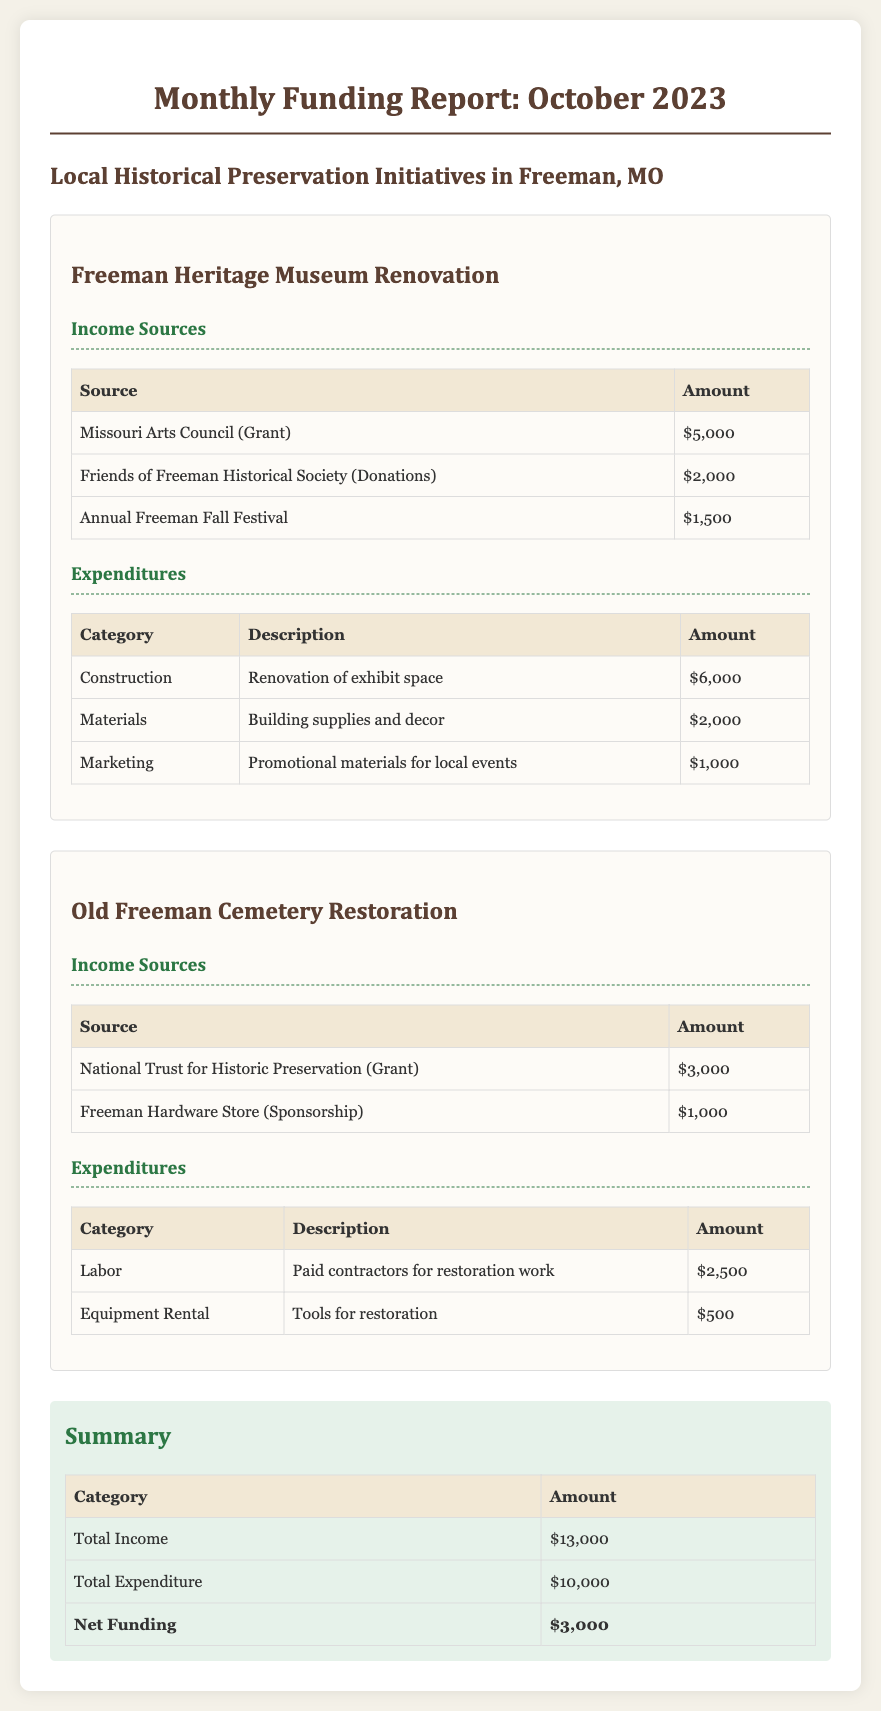What is the total income for October 2023? The total income is the sum of all income sources listed in the document, which is $5,000 + $2,000 + $1,500 + $3,000 + $1,000 = $13,000.
Answer: $13,000 What is the amount allocated for construction in the Freeman Heritage Museum Renovation? The construction expenditure for the Freeman Heritage Museum Renovation is $6,000 as displayed in the expenditures table.
Answer: $6,000 What is the name of the grant received from the Missouri Arts Council? The grant received from the Missouri Arts Council is specifically noted in the income sources of the Freeman Heritage Museum renovation section.
Answer: Missouri Arts Council (Grant) How much was sponsored by the Freeman Hardware Store? The sponsorship amount from the Freeman Hardware Store is specified in the income sources for the Old Freeman Cemetery Restoration initiative.
Answer: $1,000 What is the net funding reported for October 2023? The net funding is calculated by subtracting the total expenditure from the total income, which is $13,000 - $10,000 = $3,000.
Answer: $3,000 Which initiative received $3,000 from a grant in the income sources? The income source of $3,000 is associated with a grant from the National Trust for Historic Preservation, linked to the Old Freeman Cemetery Restoration.
Answer: Old Freeman Cemetery Restoration What is the total amount spent on materials for the Freeman Heritage Museum Renovation? The amount spent on materials for the Freeman Heritage Museum Renovation is detailed in the expenditures as $2,000.
Answer: $2,000 Who contributed $2,000 in donations for the Freeman Heritage Museum? The contribution of $2,000 in donations is attributed to the Friends of Freeman Historical Society.
Answer: Friends of Freeman Historical Society (Donations) What is the expenditure for labor in the Old Freeman Cemetery Restoration? The expenditure for labor in the Old Freeman Cemetery Restoration initiative is explicitly given in the expenditures as $2,500.
Answer: $2,500 